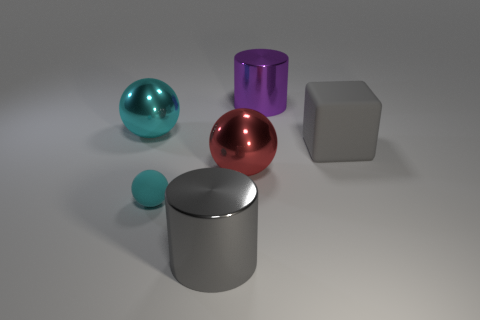Add 2 purple metal things. How many objects exist? 8 Subtract all big metal balls. How many balls are left? 1 Subtract all cubes. How many objects are left? 5 Subtract 1 cylinders. How many cylinders are left? 1 Subtract all blue blocks. Subtract all green cylinders. How many blocks are left? 1 Subtract all yellow cubes. How many green spheres are left? 0 Subtract all large metal cylinders. Subtract all big cyan metal objects. How many objects are left? 3 Add 4 gray shiny cylinders. How many gray shiny cylinders are left? 5 Add 4 large red objects. How many large red objects exist? 5 Subtract all cyan balls. How many balls are left? 1 